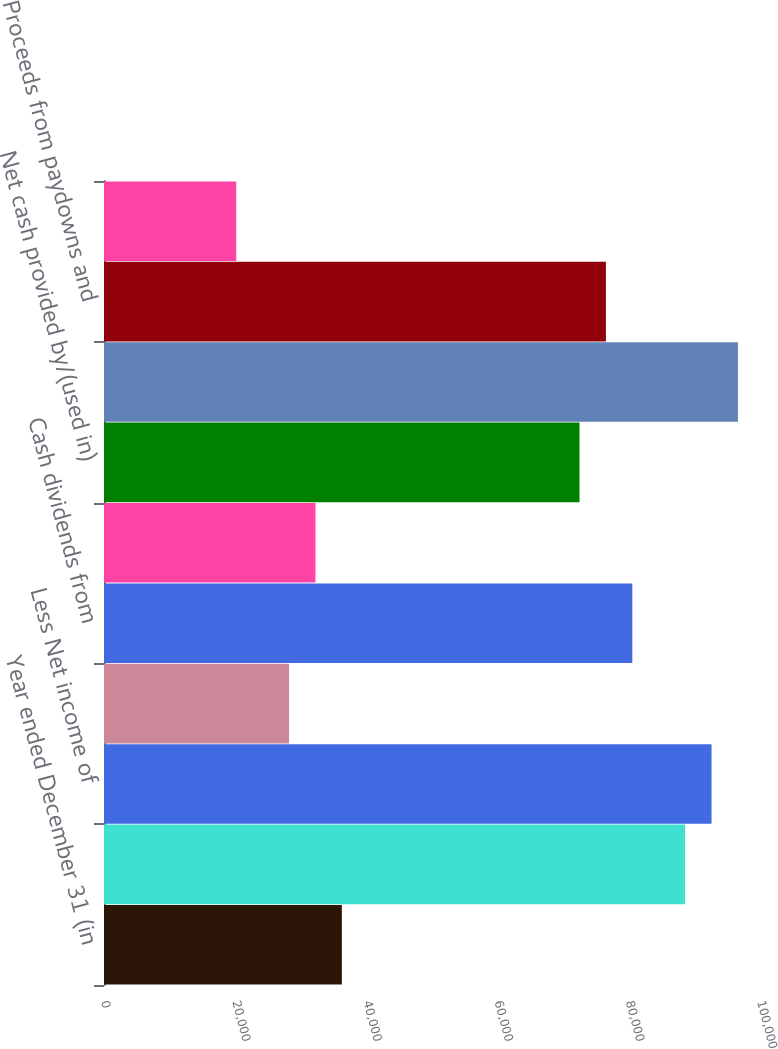<chart> <loc_0><loc_0><loc_500><loc_500><bar_chart><fcel>Year ended December 31 (in<fcel>Net income<fcel>Less Net income of<fcel>Parent company net loss<fcel>Cash dividends from<fcel>Other operating adjustments<fcel>Net cash provided by/(used in)<fcel>Deposits with banking<fcel>Proceeds from paydowns and<fcel>Other changes in loans net<nl><fcel>36258.8<fcel>88586.4<fcel>92611.6<fcel>28208.4<fcel>80536<fcel>32233.6<fcel>72485.6<fcel>96636.8<fcel>76510.8<fcel>20158<nl></chart> 